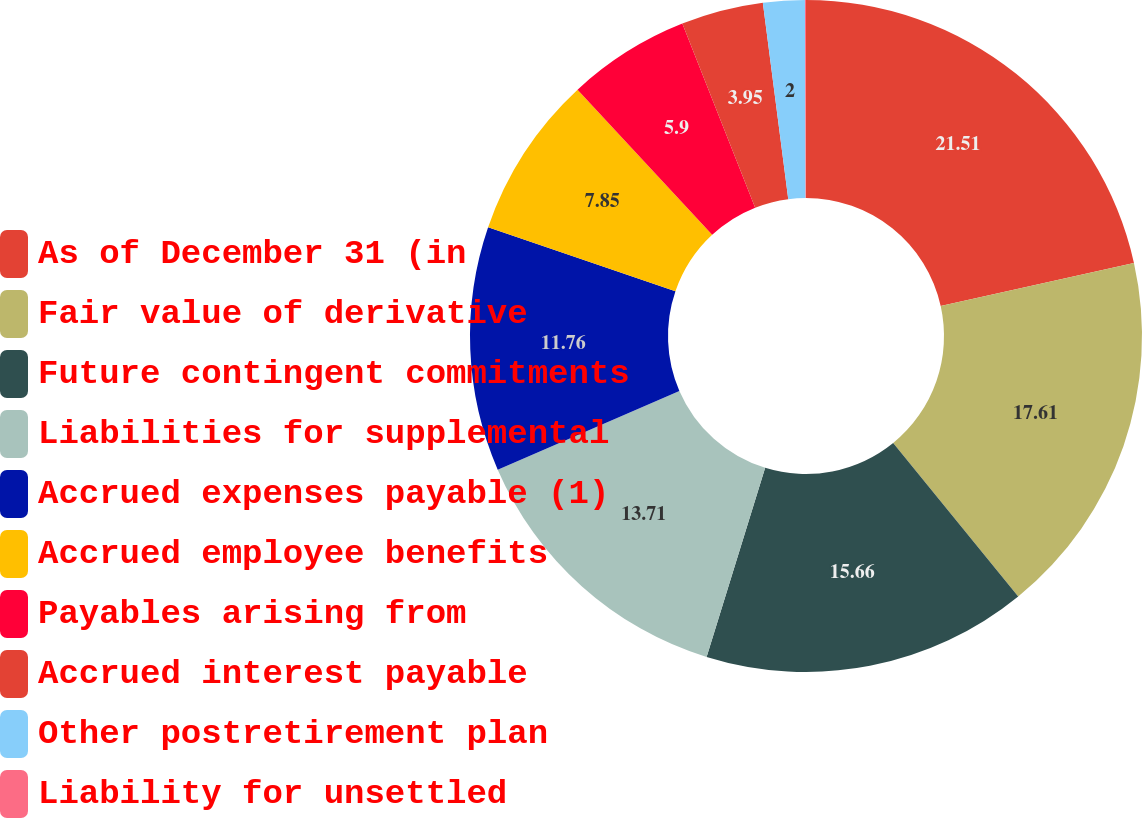Convert chart. <chart><loc_0><loc_0><loc_500><loc_500><pie_chart><fcel>As of December 31 (in<fcel>Fair value of derivative<fcel>Future contingent commitments<fcel>Liabilities for supplemental<fcel>Accrued expenses payable (1)<fcel>Accrued employee benefits<fcel>Payables arising from<fcel>Accrued interest payable<fcel>Other postretirement plan<fcel>Liability for unsettled<nl><fcel>21.51%<fcel>17.61%<fcel>15.66%<fcel>13.71%<fcel>11.76%<fcel>7.85%<fcel>5.9%<fcel>3.95%<fcel>2.0%<fcel>0.05%<nl></chart> 